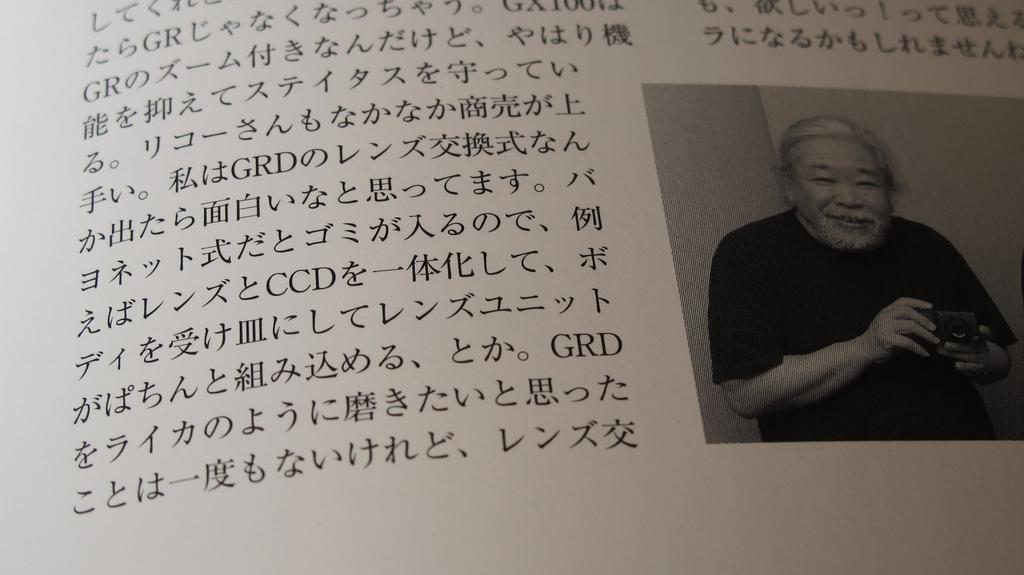What is the main object in the image? There is a paper in the image. What is depicted on the paper? The paper has a picture of a man. What is the man in the picture doing? The man in the picture is holding a camera. Is there any text on the paper? Yes, there is text written on the paper. Can you see any farmers working in the fields in the image? There is no reference to a farmer or a field in the image; it features a paper with a picture of a man holding a camera. Is the seashore visible in the image? There is no indication of a seashore in the image; it focuses on a paper with a picture of a man holding a camera. 